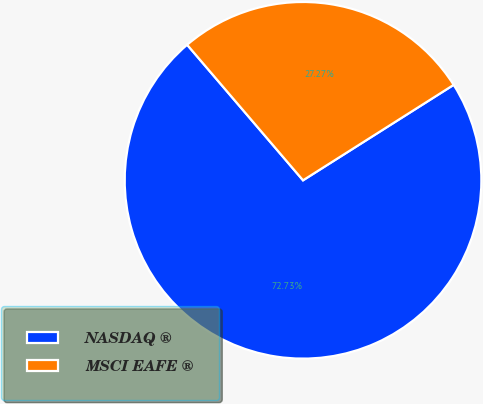Convert chart. <chart><loc_0><loc_0><loc_500><loc_500><pie_chart><fcel>NASDAQ ®<fcel>MSCI EAFE ®<nl><fcel>72.73%<fcel>27.27%<nl></chart> 